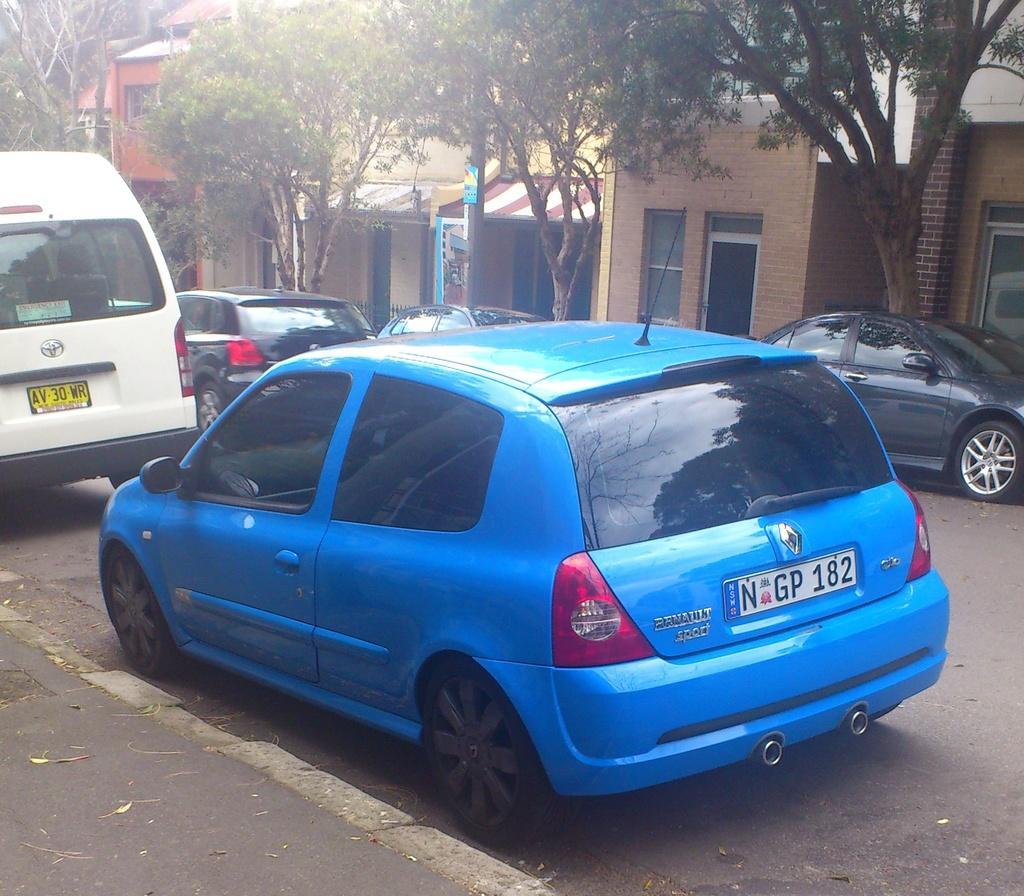Could you give a brief overview of what you see in this image? In this image there are a few vehicles on the road. In the background there are buildings and trees. 